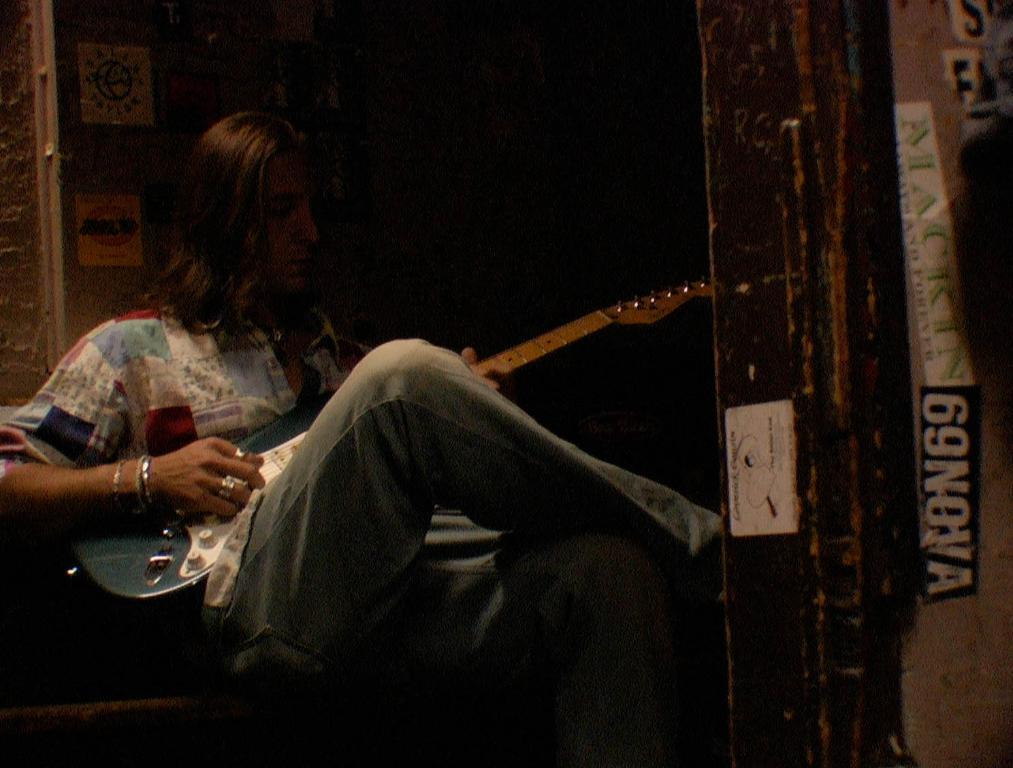Provide a one-sentence caption for the provided image. A person playing the guitar with a sticker on the door of 69Nova. 